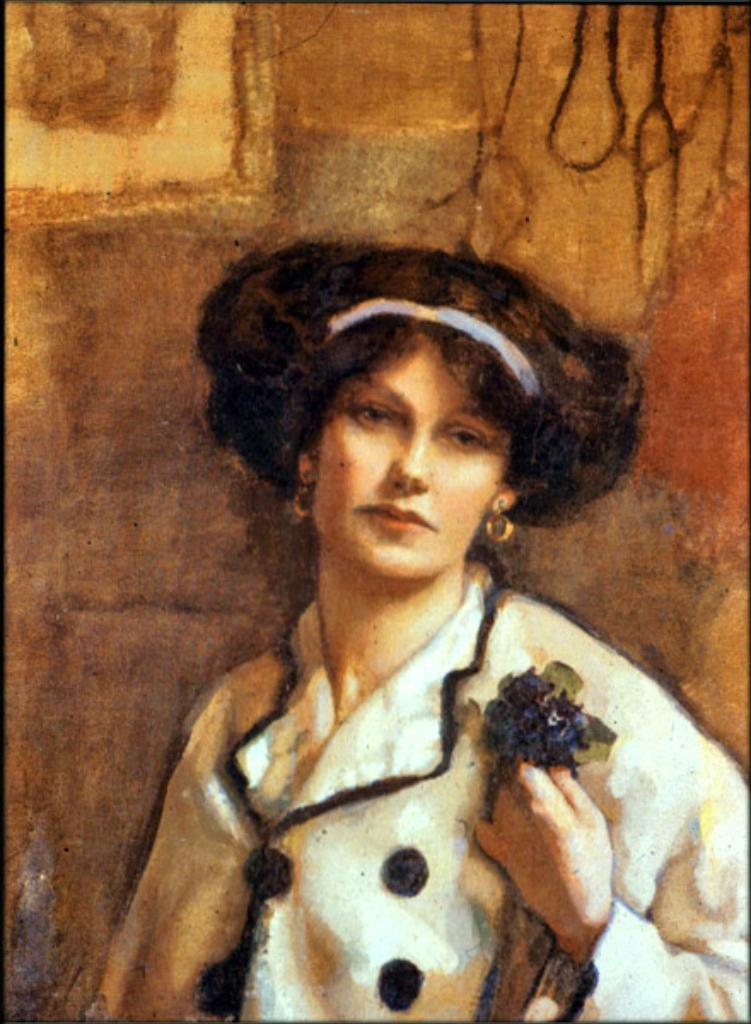How was the image altered or modified? The image is edited, which means it has been changed or manipulated in some way. What can be seen in the background of the image? There is a wall in the background of the image. Who is the main subject in the image? There is a woman in the middle of the image. What type of meal is being prepared by the woman in the image? There is no indication in the image that the woman is preparing a meal, so it cannot be determined from the picture. 